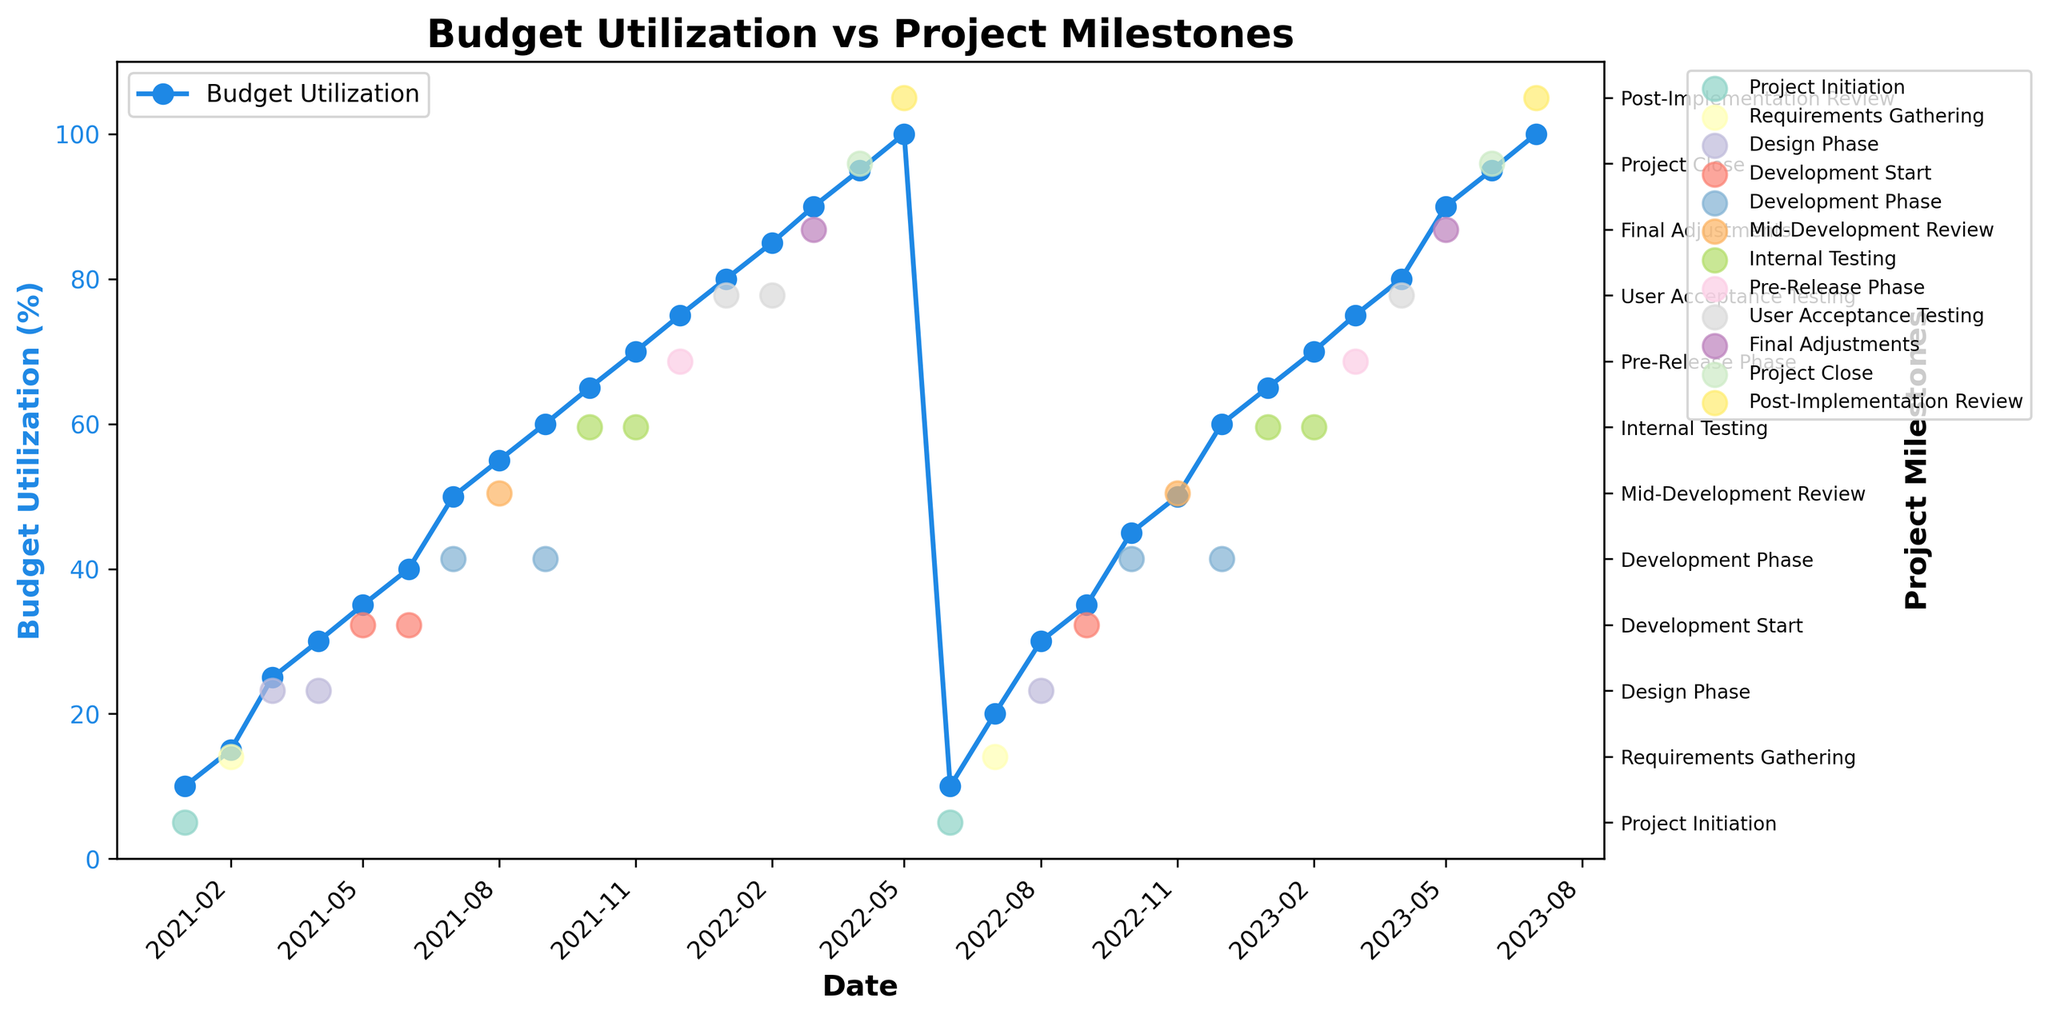What's the title of the figure? The title of the figure is prominently displayed at the top.
Answer: Budget Utilization vs Project Milestones What is the budget utilization percentage in March 2022? Locate March 2022 on the x-axis and refer to the corresponding point on the Budget Utilization line.
Answer: 90% How many project milestones are represented in the figure? Examine the y-axis on the right side where project milestones are labeled. Count the unique milestone labels.
Answer: 10 Comparing January 2021 and January 2022, which month had a higher budget utilization? Identify the budget utilization percentages for both months and compare them. January 2022 shows 80%, while January 2021 shows 10%.
Answer: January 2022 What is the average budget utilization percentage from January 2021 to June 2021? Locate the budget utilization percentages from January 2021 to June 2021 (10, 15, 25, 30, 35, 40). Add them and divide by 6. (10 + 15 + 25 + 30 + 35 + 40 = 155; 155/6 = 25.83).
Answer: 25.83% What milestone occurs at the highest budget utilization percentage? Identify the maximum budget utilization percentage and determine the milestone that occurs at this point.
Answer: Post-Implementation Review In which month does the 'Mid-Development Review' milestone occur in the year 2022? Locate the 'Mid-Development Review' milestone on the y-axis and track its corresponding month on the x-axis.
Answer: November 2022 Which milestone's budget utilization first reaches 50%? Identify the milestone label that first coincides with a budget utilization percentage of 50%.
Answer: Development Phase By how much does the budget utilization increase from the 'Development Start' to the 'Final Adjustments' in 2023? Determine the budget utilization percentages for 'Development Start' and 'Final Adjustments' in 2023, then calculate the difference (90% - 35%).
Answer: 55% What’s the trend of the budget utilization percentage during the 'Internal Testing' phases in both years? Review the budget utilization percentages during the 'Internal Testing' phases for both years (65%, 70%). Since they remain constant in both years, they are increasing steadily in short periods.
Answer: Increasing 